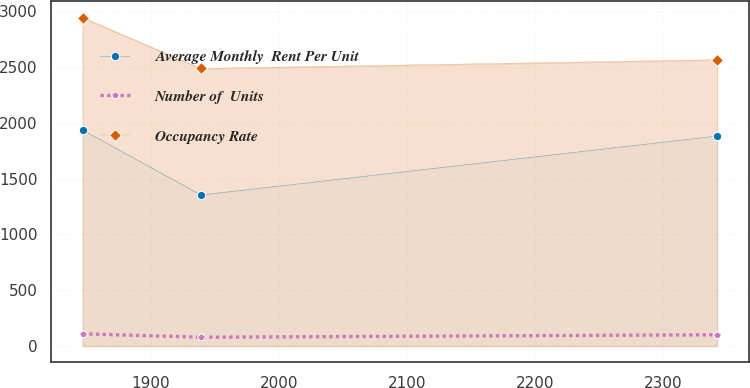Convert chart to OTSL. <chart><loc_0><loc_0><loc_500><loc_500><line_chart><ecel><fcel>Average Monthly  Rent Per Unit<fcel>Number of  Units<fcel>Occupancy Rate<nl><fcel>1846.44<fcel>1936.68<fcel>109.67<fcel>2945.29<nl><fcel>1939.05<fcel>1354.18<fcel>78.81<fcel>2488.51<nl><fcel>2342.5<fcel>1882.51<fcel>100.86<fcel>2567.1<nl></chart> 